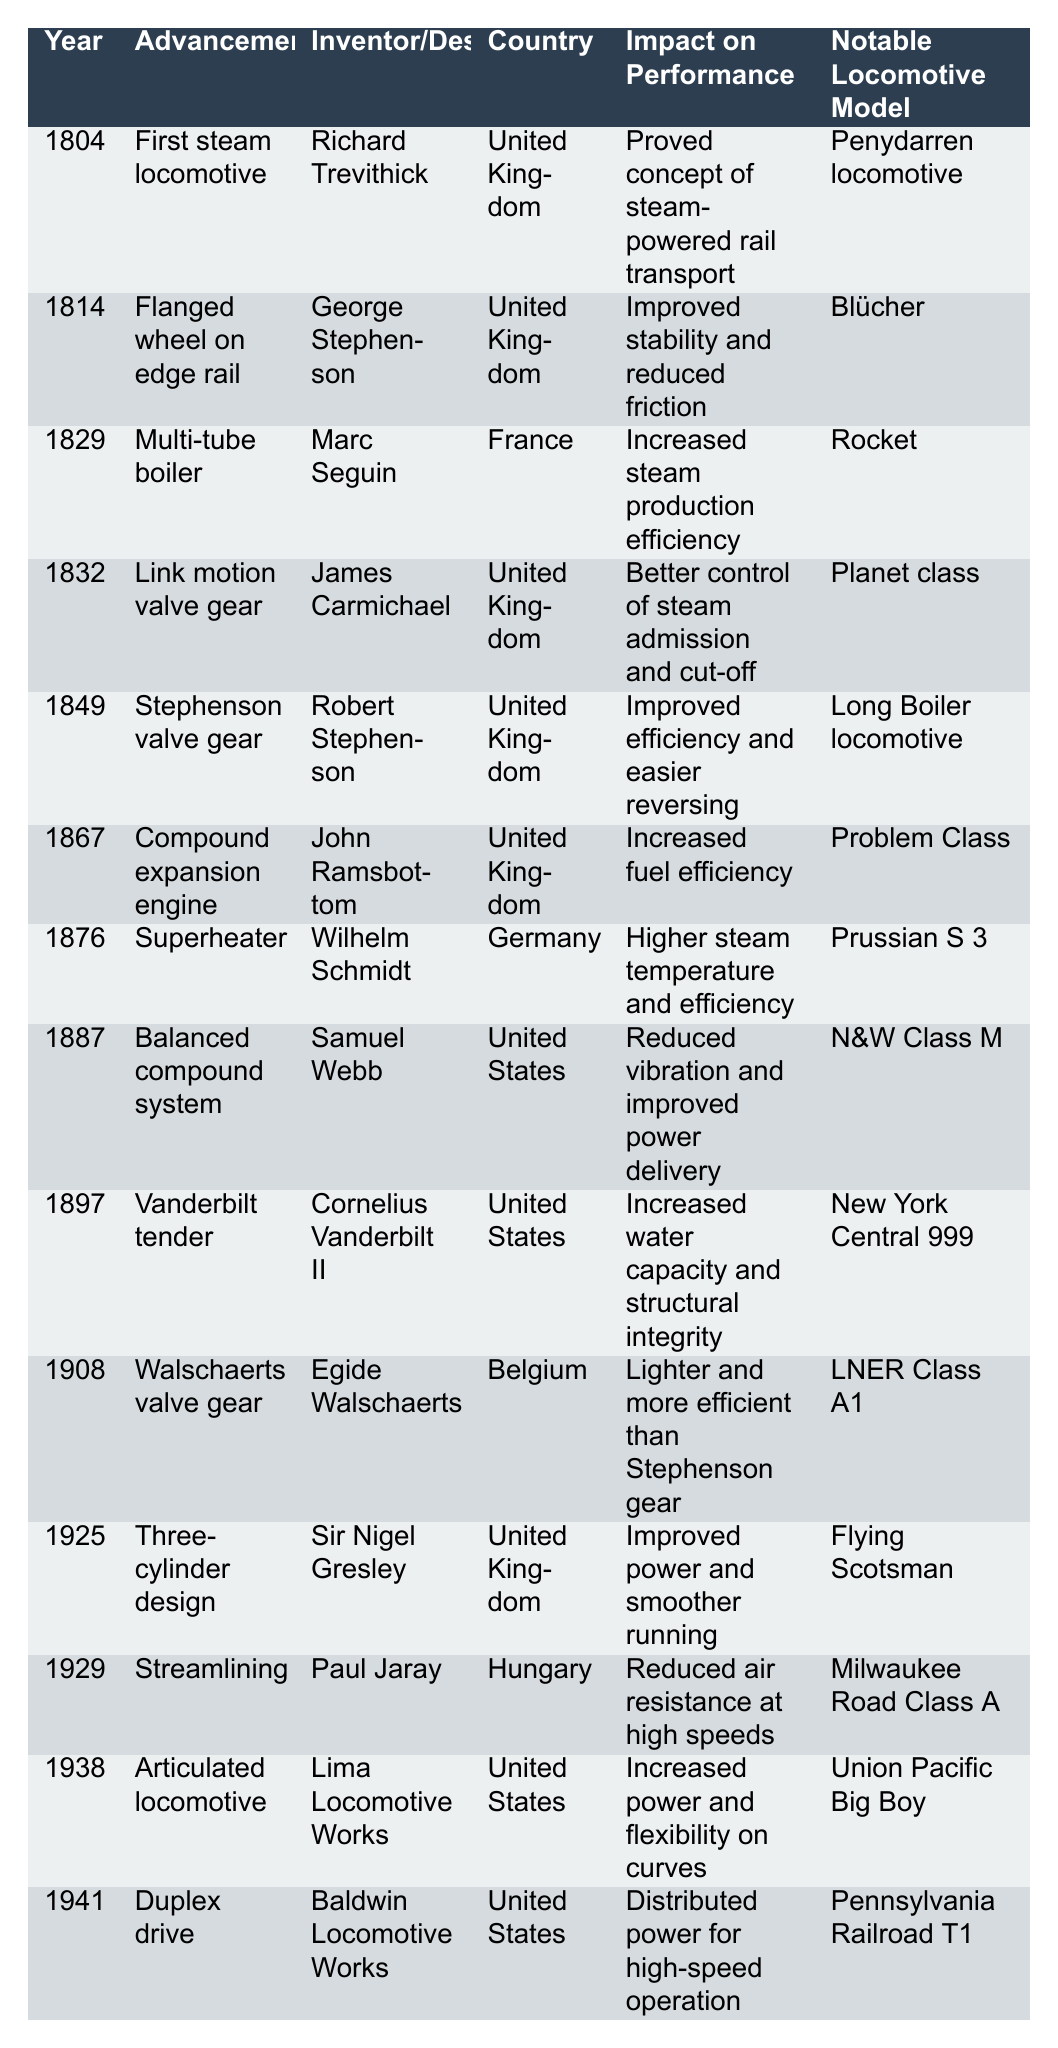What year was the first steam locomotive invented? The table shows that the first steam locomotive was invented in the year 1804 by Richard Trevithick.
Answer: 1804 Who invented the multi-tube boiler and in which country? According to the table, the multi-tube boiler was invented by Marc Seguin in France.
Answer: Marc Seguin, France Which locomotive model is associated with the introduction of the compound expansion engine? The table indicates that the Problem Class locomotive is associated with the introduction of the compound expansion engine in 1867.
Answer: Problem Class What impact did the superheater have on steam locomotives? The superheater, introduced in 1876, increased the steam temperature and efficiency, as stated in the impact section of the table.
Answer: Higher steam temperature and efficiency How many advancements were made in steam locomotive design between 1804 and 1908? By counting the rows in the table for advancements from 1804 to 1908, there are 8 advancements made in this time frame.
Answer: 8 Which advancement provided better control of steam admission and cut-off? The link motion valve gear, introduced in 1832 by James Carmichael, provided better control of steam admission and cut-off as noted in the table.
Answer: Link motion valve gear True or False: The Vanderbilt tender increased fuel efficiency. The table states that the Vanderbilt tender increased water capacity and structural integrity, not fuel efficiency; hence, the statement is false.
Answer: False What was the notable locomotive model for the advancement in streamlining? The table shows that the notable locomotive model for the advancement in streamlining, introduced in 1929, is the Milwaukee Road Class A.
Answer: Milwaukee Road Class A Which country saw the introduction of the Walschaerts valve gear? According to the table, the Walschaerts valve gear was introduced in Belgium, thus it is associated with Belgium.
Answer: Belgium Which advancements occurred in the United States and what years were they introduced? The table lists three advancements in the United States: the balanced compound system in 1887, the Vanderbilt tender in 1897, and the articulated locomotive in 1938.
Answer: 1887, 1897, 1938 What is the difference in years between the introduction of the first steam locomotive and the duplex drive? The first steam locomotive was introduced in 1804, and the duplex drive was introduced in 1941. The difference is 1941 - 1804 = 137 years.
Answer: 137 years Which advancement had the greatest impact on railroad performance? The question is subjective, but based on the impacts listed, the duplex drive introduced in 1941 allowed for distributed power for high-speed operations, which can be considered significant.
Answer: Duplex drive 